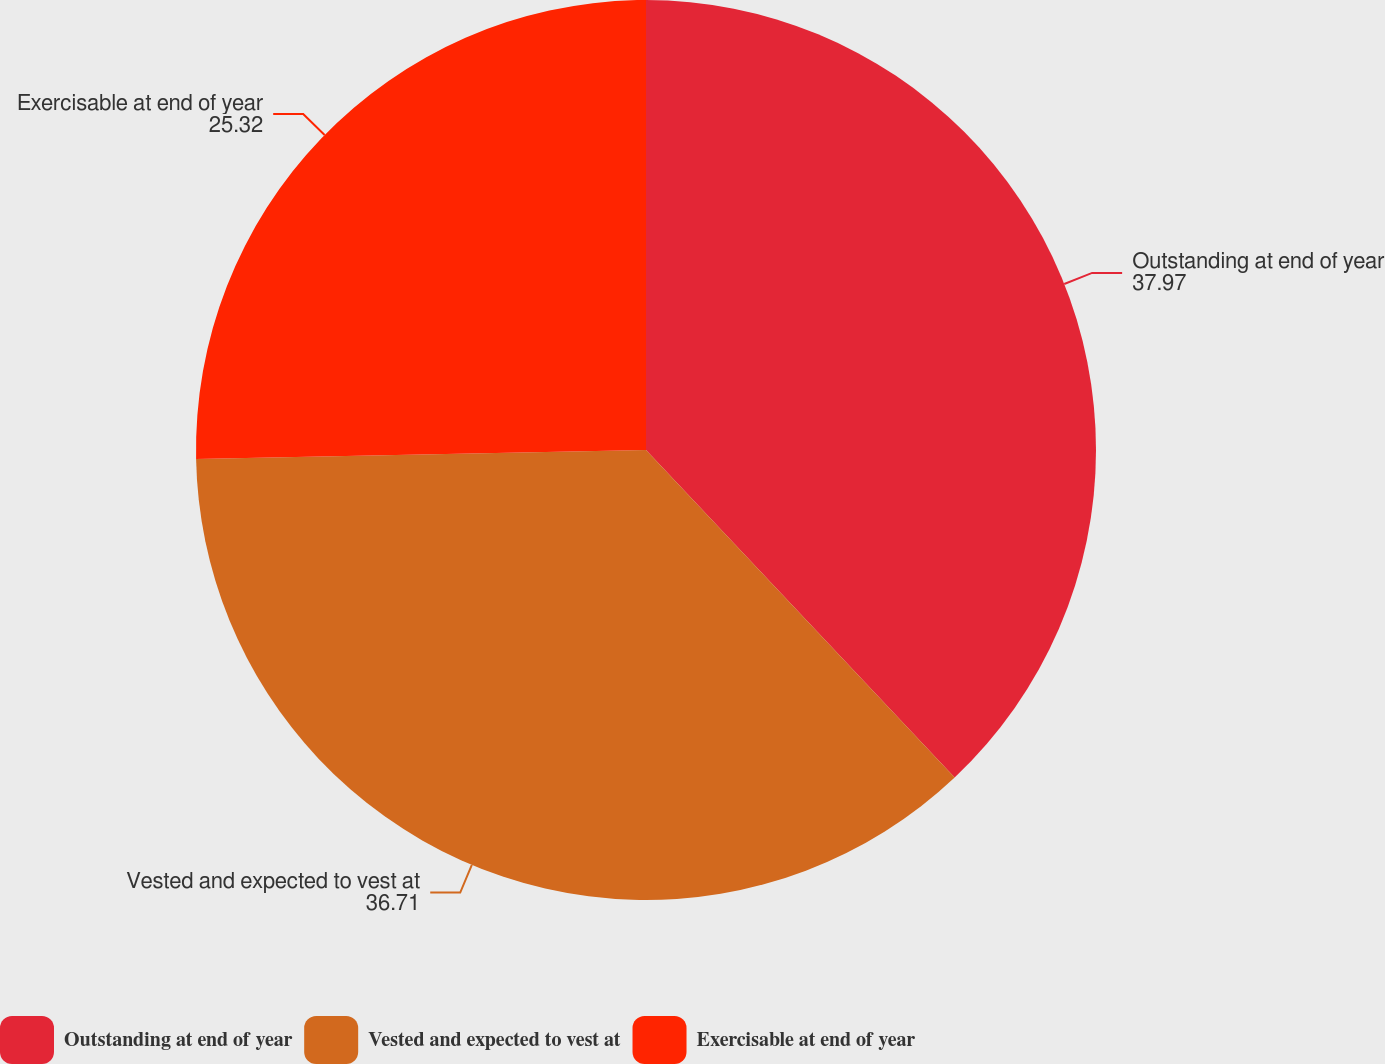Convert chart to OTSL. <chart><loc_0><loc_0><loc_500><loc_500><pie_chart><fcel>Outstanding at end of year<fcel>Vested and expected to vest at<fcel>Exercisable at end of year<nl><fcel>37.97%<fcel>36.71%<fcel>25.32%<nl></chart> 